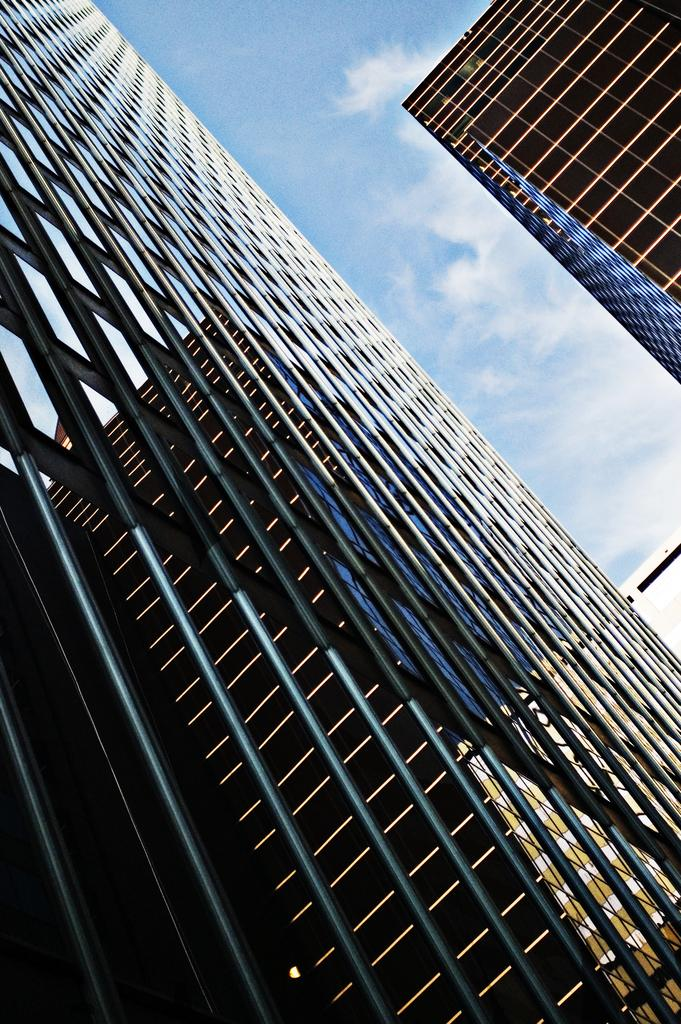What type of structures can be seen in the image? There are buildings in the image. What part of the natural environment is visible in the image? The sky is visible in the image. What type of lumber is being used to construct the buildings in the image? There is no information about the construction materials of the buildings in the image, so it cannot be determined from the image. 